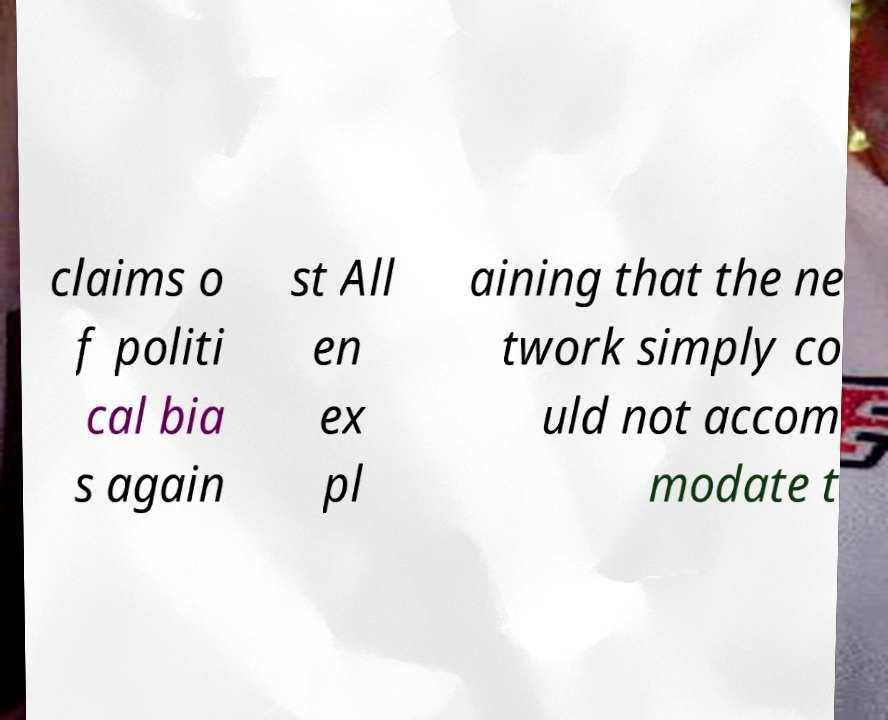Could you assist in decoding the text presented in this image and type it out clearly? claims o f politi cal bia s again st All en ex pl aining that the ne twork simply co uld not accom modate t 